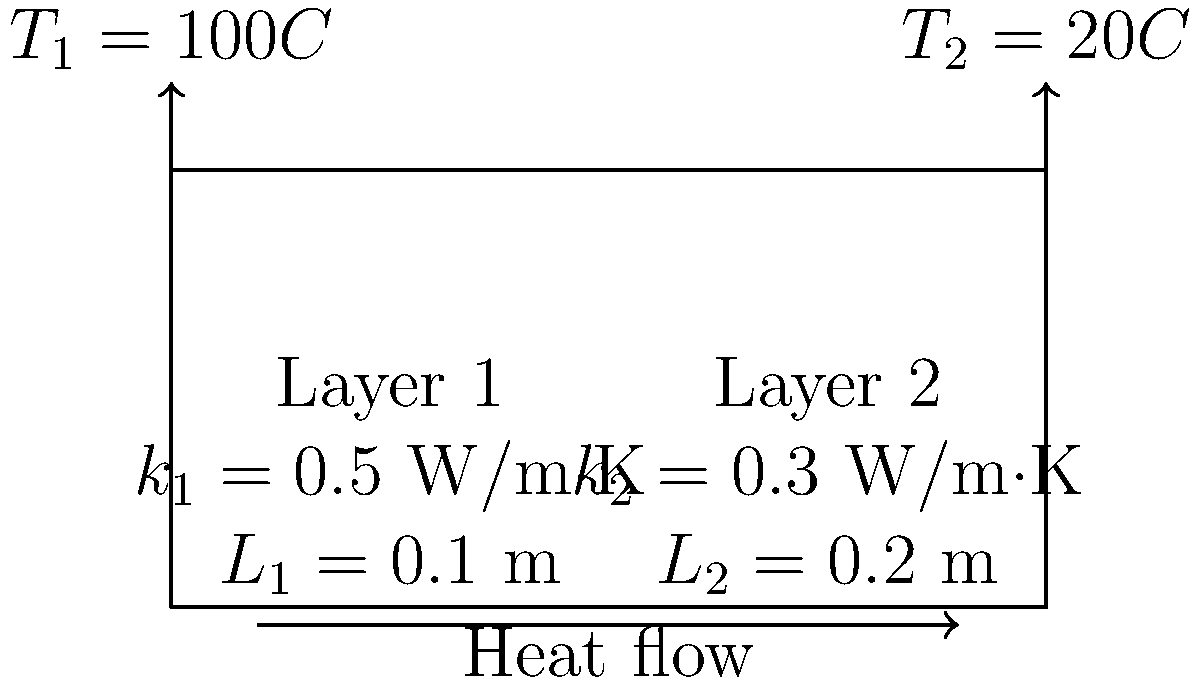As a startup founder developing a playlist algorithm, you're working on optimizing server room cooling. You encounter a composite wall in the server room with two layers of different materials. The inner surface temperature (T₁) is 100°C, and the outer surface temperature (T₂) is 20°C. Layer 1 has a thermal conductivity (k₁) of 0.5 W/m·K and thickness (L₁) of 0.1 m, while Layer 2 has a thermal conductivity (k₂) of 0.3 W/m·K and thickness (L₂) of 0.2 m. Calculate the heat transfer rate per unit area through this composite wall. To solve this problem, we'll use the concept of thermal resistance in series for a composite wall. Here's the step-by-step solution:

1. Calculate the thermal resistance of each layer:
   R₁ = L₁ / k₁ = 0.1 m / (0.5 W/m·K) = 0.2 m²·K/W
   R₂ = L₂ / k₂ = 0.2 m / (0.3 W/m·K) = 0.667 m²·K/W

2. Calculate the total thermal resistance:
   R_total = R₁ + R₂ = 0.2 + 0.667 = 0.867 m²·K/W

3. Use Fourier's Law of heat conduction for composite walls:
   q = (T₁ - T₂) / R_total
   where q is the heat transfer rate per unit area

4. Substitute the values:
   q = (100°C - 20°C) / 0.867 m²·K/W
   q = 80 / 0.867 = 92.27 W/m²

Therefore, the heat transfer rate per unit area through the composite wall is approximately 92.27 W/m².
Answer: 92.27 W/m² 